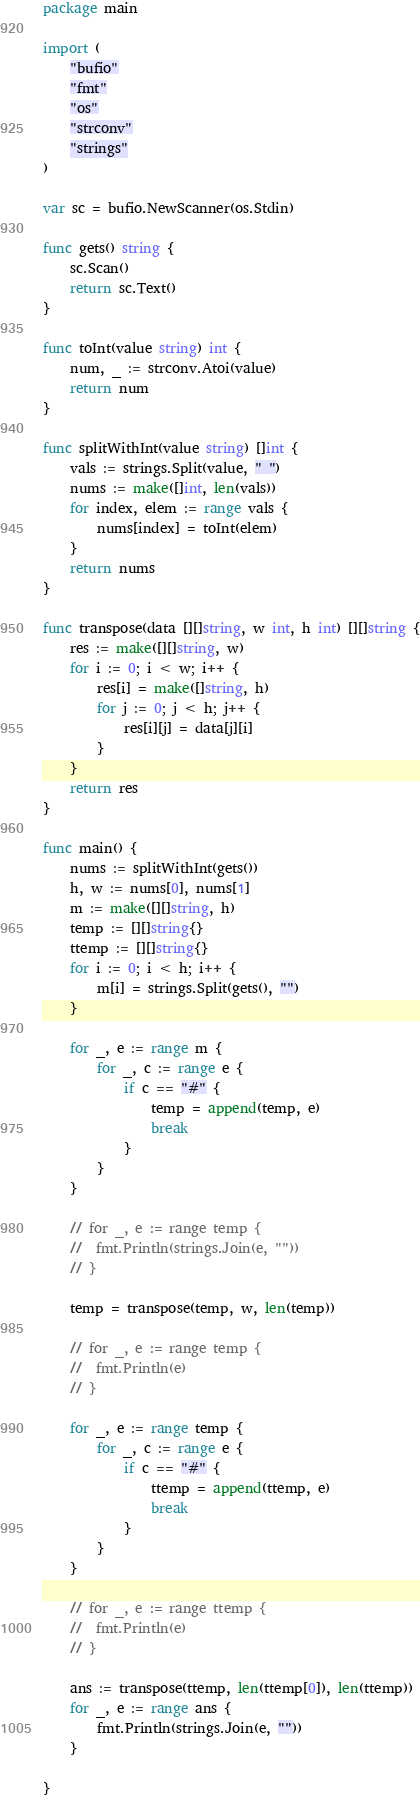Convert code to text. <code><loc_0><loc_0><loc_500><loc_500><_Go_>package main

import (
	"bufio"
	"fmt"
	"os"
	"strconv"
	"strings"
)

var sc = bufio.NewScanner(os.Stdin)

func gets() string {
	sc.Scan()
	return sc.Text()
}

func toInt(value string) int {
	num, _ := strconv.Atoi(value)
	return num
}

func splitWithInt(value string) []int {
	vals := strings.Split(value, " ")
	nums := make([]int, len(vals))
	for index, elem := range vals {
		nums[index] = toInt(elem)
	}
	return nums
}

func transpose(data [][]string, w int, h int) [][]string {
	res := make([][]string, w)
	for i := 0; i < w; i++ {
		res[i] = make([]string, h)
		for j := 0; j < h; j++ {
			res[i][j] = data[j][i]
		}
	}
	return res
}

func main() {
	nums := splitWithInt(gets())
	h, w := nums[0], nums[1]
	m := make([][]string, h)
	temp := [][]string{}
	ttemp := [][]string{}
	for i := 0; i < h; i++ {
		m[i] = strings.Split(gets(), "")
	}

	for _, e := range m {
		for _, c := range e {
			if c == "#" {
				temp = append(temp, e)
				break
			}
		}
	}

	// for _, e := range temp {
	// 	fmt.Println(strings.Join(e, ""))
	// }

	temp = transpose(temp, w, len(temp))

	// for _, e := range temp {
	// 	fmt.Println(e)
	// }

	for _, e := range temp {
		for _, c := range e {
			if c == "#" {
				ttemp = append(ttemp, e)
				break
			}
		}
	}

	// for _, e := range ttemp {
	// 	fmt.Println(e)
	// }

	ans := transpose(ttemp, len(ttemp[0]), len(ttemp))
	for _, e := range ans {
		fmt.Println(strings.Join(e, ""))
	}

}</code> 